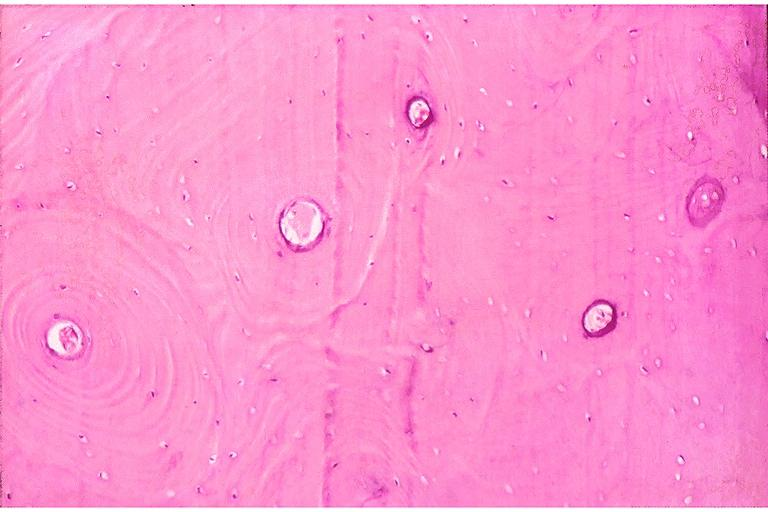s oral present?
Answer the question using a single word or phrase. Yes 